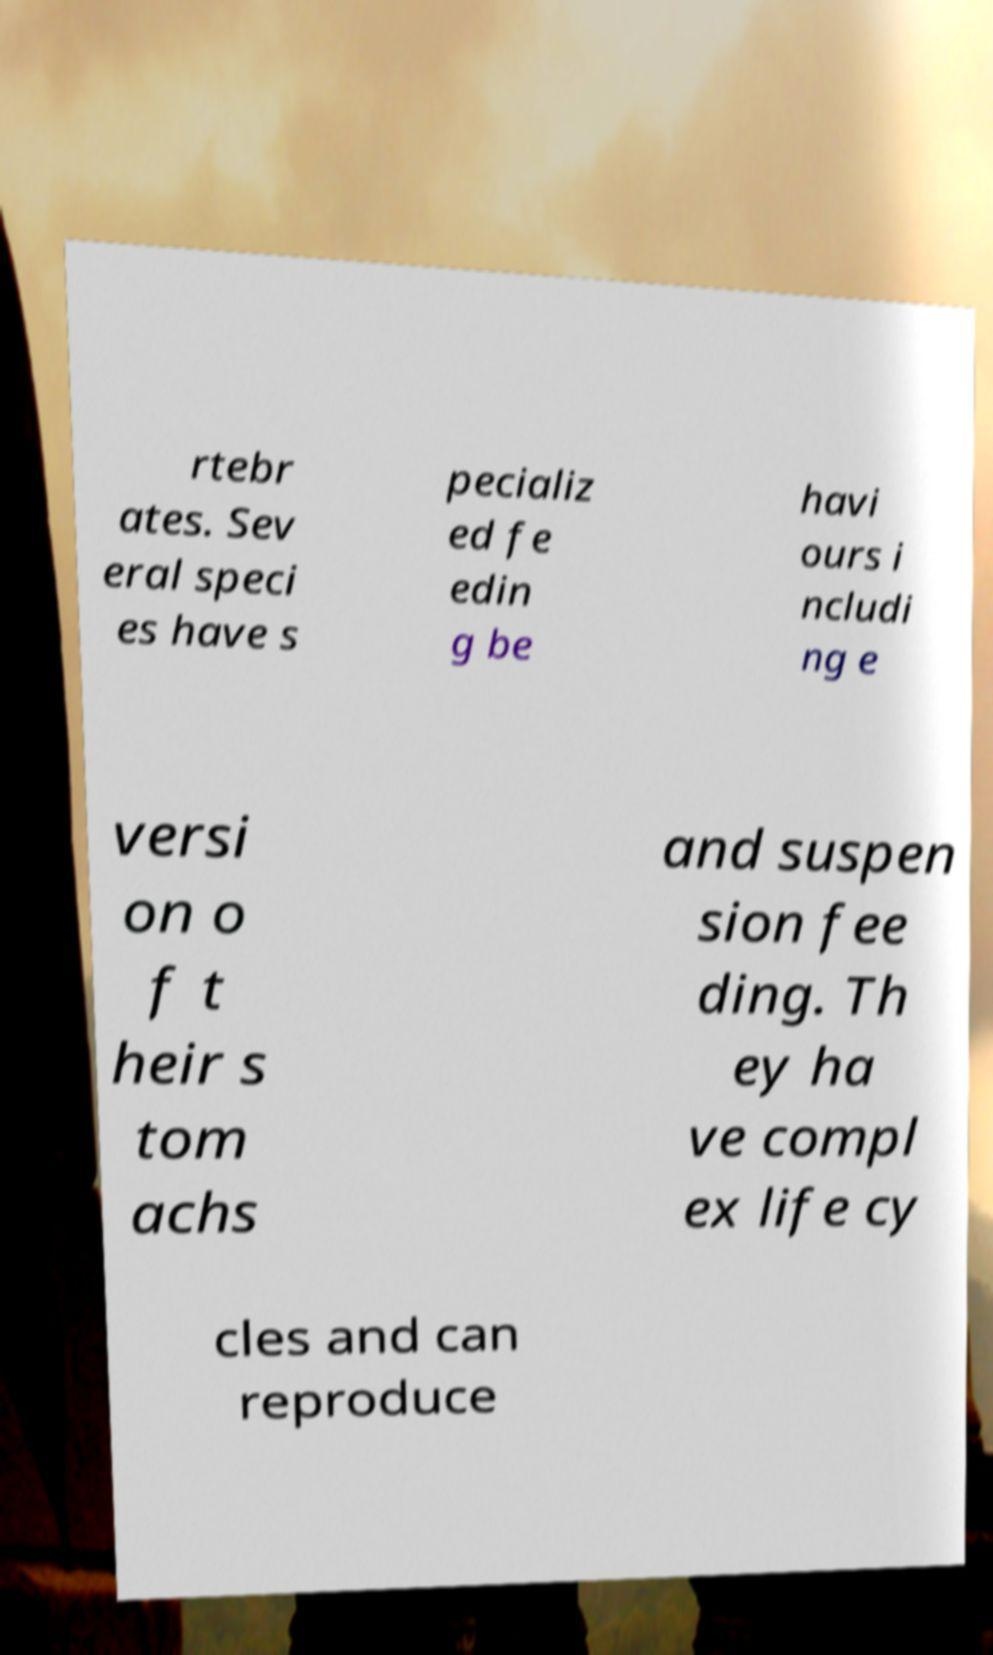Can you read and provide the text displayed in the image?This photo seems to have some interesting text. Can you extract and type it out for me? rtebr ates. Sev eral speci es have s pecializ ed fe edin g be havi ours i ncludi ng e versi on o f t heir s tom achs and suspen sion fee ding. Th ey ha ve compl ex life cy cles and can reproduce 